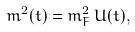Convert formula to latex. <formula><loc_0><loc_0><loc_500><loc_500>m ^ { 2 } ( t ) = m _ { F } ^ { 2 } \, U ( t ) ,</formula> 